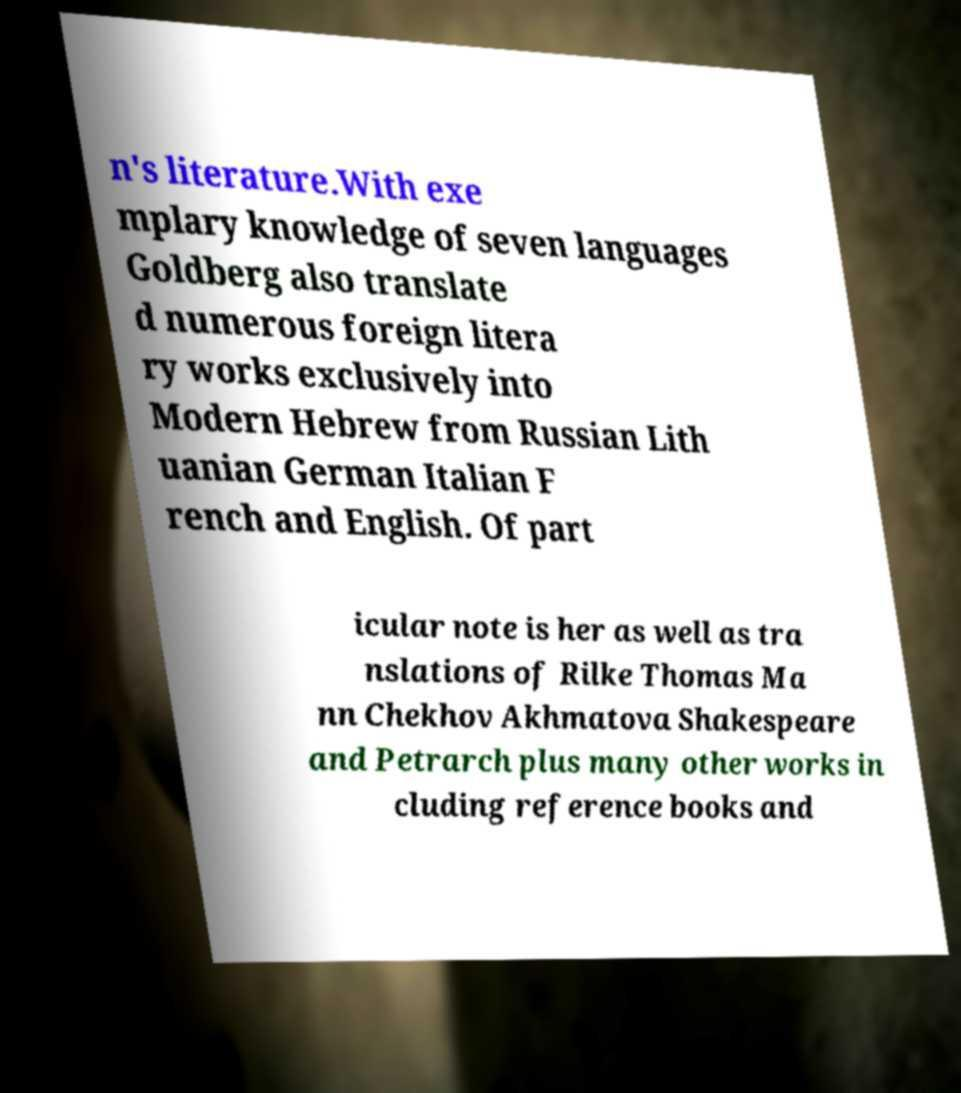Can you read and provide the text displayed in the image?This photo seems to have some interesting text. Can you extract and type it out for me? n's literature.With exe mplary knowledge of seven languages Goldberg also translate d numerous foreign litera ry works exclusively into Modern Hebrew from Russian Lith uanian German Italian F rench and English. Of part icular note is her as well as tra nslations of Rilke Thomas Ma nn Chekhov Akhmatova Shakespeare and Petrarch plus many other works in cluding reference books and 